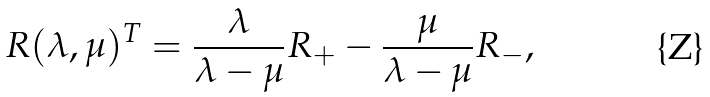Convert formula to latex. <formula><loc_0><loc_0><loc_500><loc_500>R ( \lambda , \mu ) ^ { T } = \frac { \lambda } { \lambda - \mu } R _ { + } - \frac { \mu } { \lambda - \mu } R _ { - } ,</formula> 